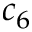<formula> <loc_0><loc_0><loc_500><loc_500>c _ { 6 }</formula> 